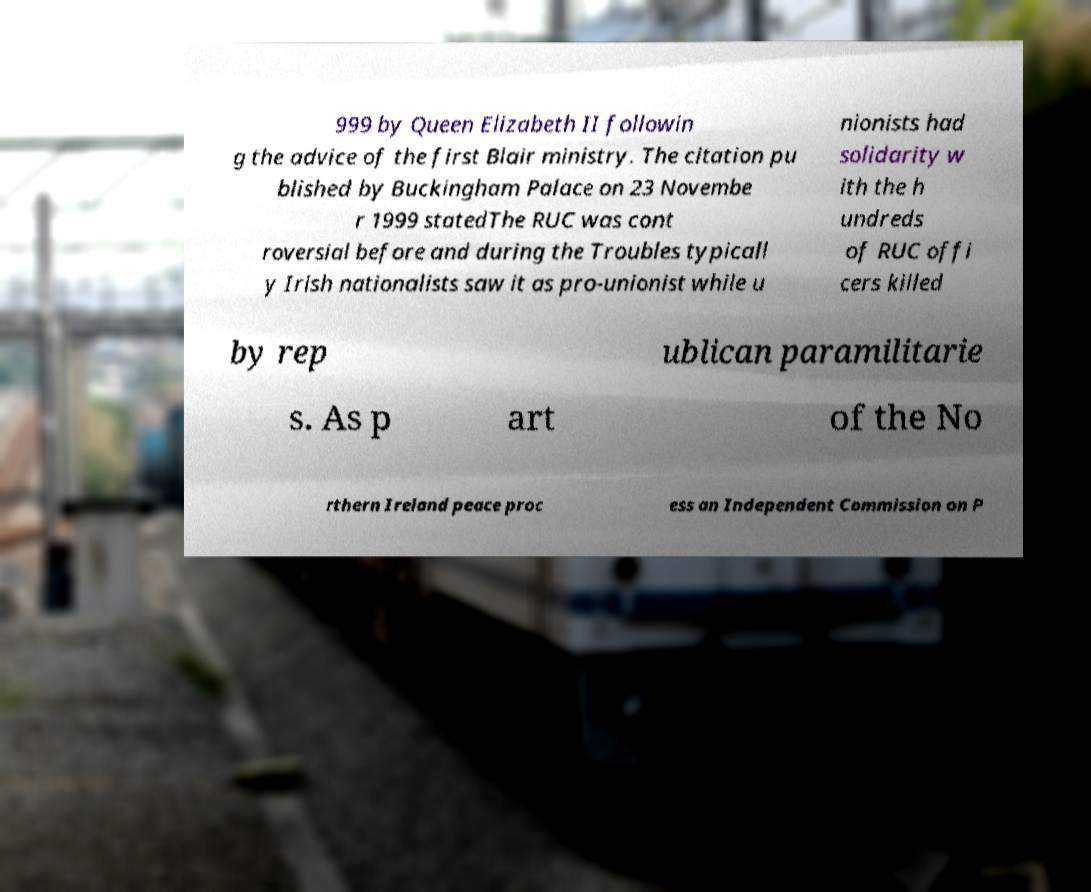Can you read and provide the text displayed in the image?This photo seems to have some interesting text. Can you extract and type it out for me? 999 by Queen Elizabeth II followin g the advice of the first Blair ministry. The citation pu blished by Buckingham Palace on 23 Novembe r 1999 statedThe RUC was cont roversial before and during the Troubles typicall y Irish nationalists saw it as pro-unionist while u nionists had solidarity w ith the h undreds of RUC offi cers killed by rep ublican paramilitarie s. As p art of the No rthern Ireland peace proc ess an Independent Commission on P 